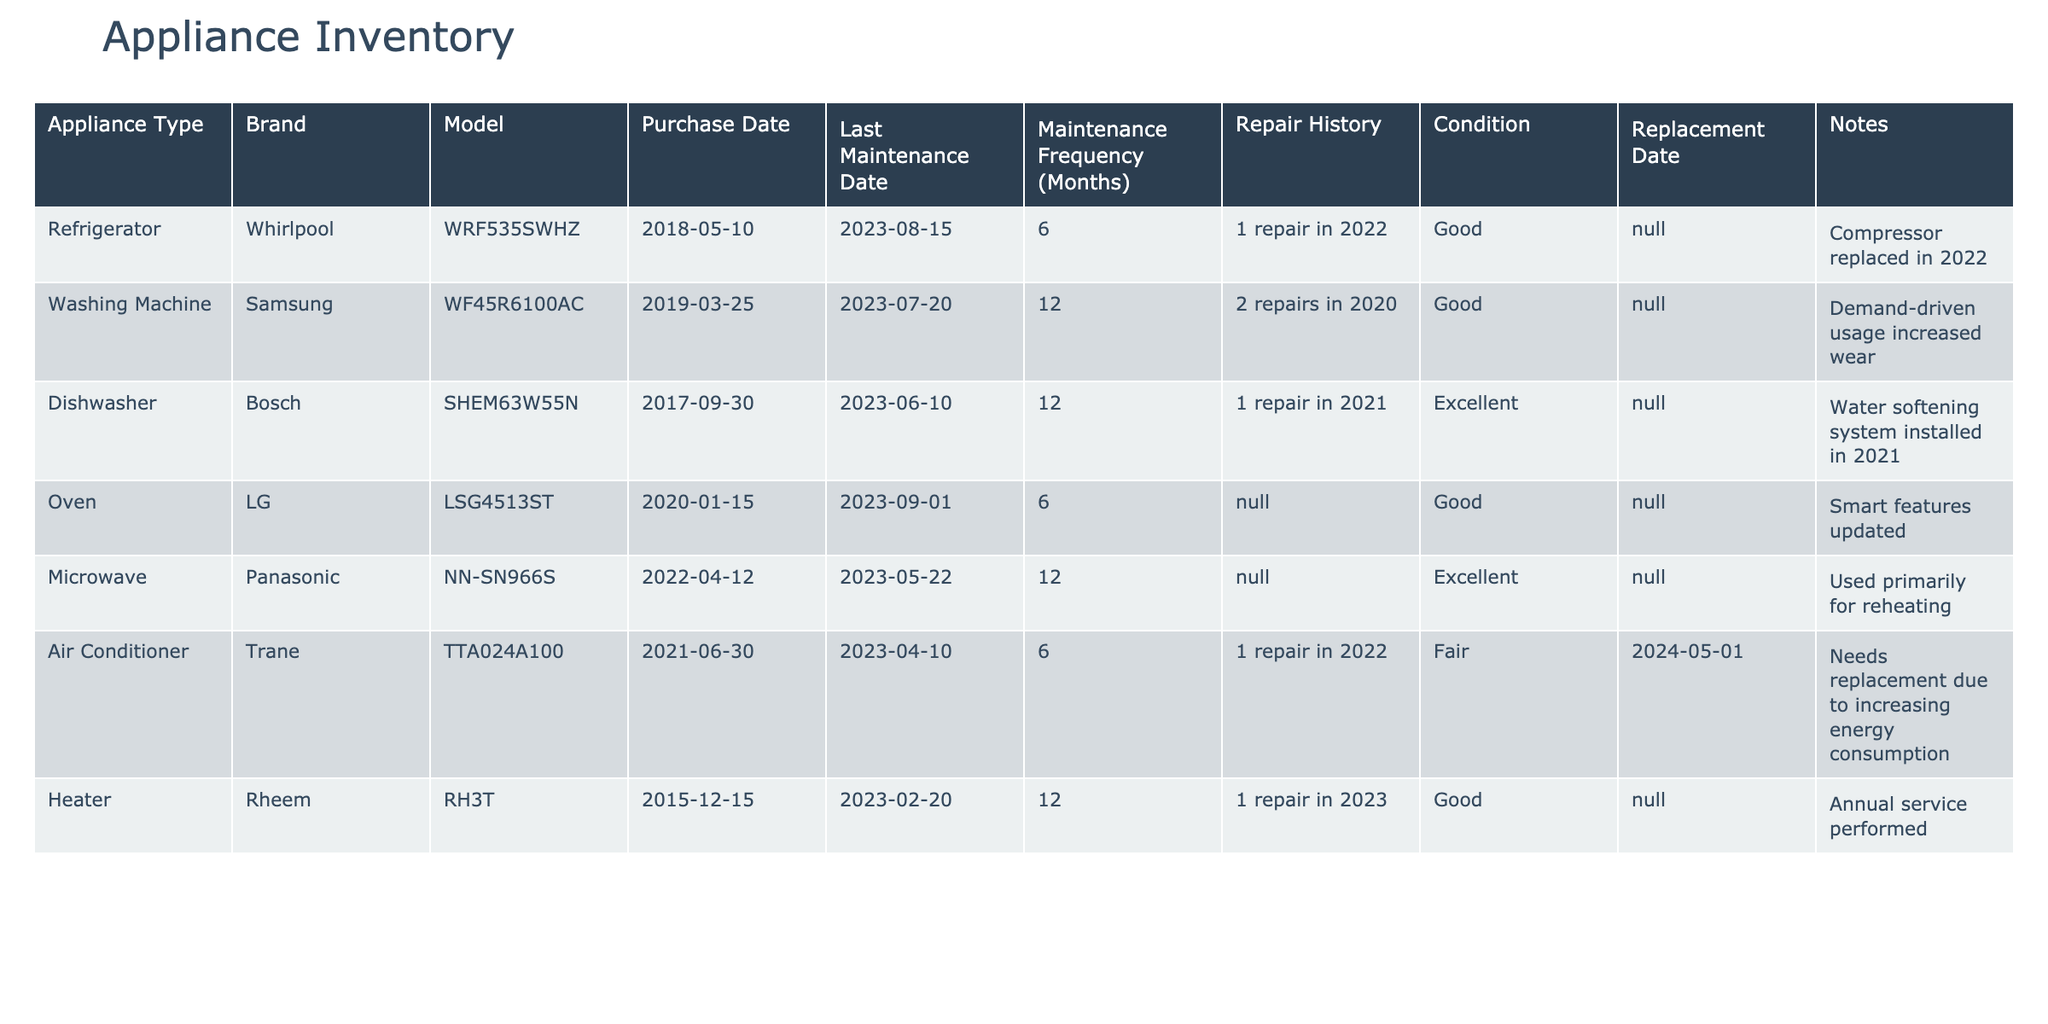What is the last maintenance date for the dishwasher? The table lists "Last Maintenance Date" for each appliance. The dishwasher is a Bosch model, and the last maintenance date listed for it is June 10, 2023.
Answer: June 10, 2023 Which appliance has the earliest purchase date? By comparing the purchase dates of all appliances, the heater is the oldest, purchased on December 15, 2015.
Answer: Heater How many repairs were made to the washing machine? The repair history for the washing machine shows that there were 2 repairs in 2020.
Answer: 2 repairs Is the air conditioner needed to be replaced? The table indicates that the air conditioner is in fair condition and has a replacement date set for May 1, 2024, which suggests that it is indeed needed to be replaced.
Answer: Yes What is the average maintenance frequency (in months) for the appliances? Adding the maintenance frequencies: 6 + 12 + 12 + 6 + 12 + 6 + 12 = 66. There are 7 appliances, so the average maintenance frequency is 66 divided by 7, which equals approximately 9.43 months.
Answer: 9.43 months What notes are provided for the refrigerator? The notes section for the refrigerator mentions that the compressor was replaced in 2022.
Answer: Compressor replaced in 2022 How many appliances have a condition rated as "Excellent"? By counting the appliances marked as "Excellent," we see that both the dishwasher and microwave fall into this category. Hence, there are 2 appliances with this condition rating.
Answer: 2 appliances Which appliance has the most recent last maintenance date? The last maintenance dates are: August 15, 2023 (refrigerator), July 20, 2023 (washing machine), June 10, 2023 (dishwasher), September 1, 2023 (oven), May 22, 2023 (microwave), April 10, 2023 (air conditioner), and February 20, 2023 (heater). The most recent date is September 1, 2023, for the oven.
Answer: Oven 